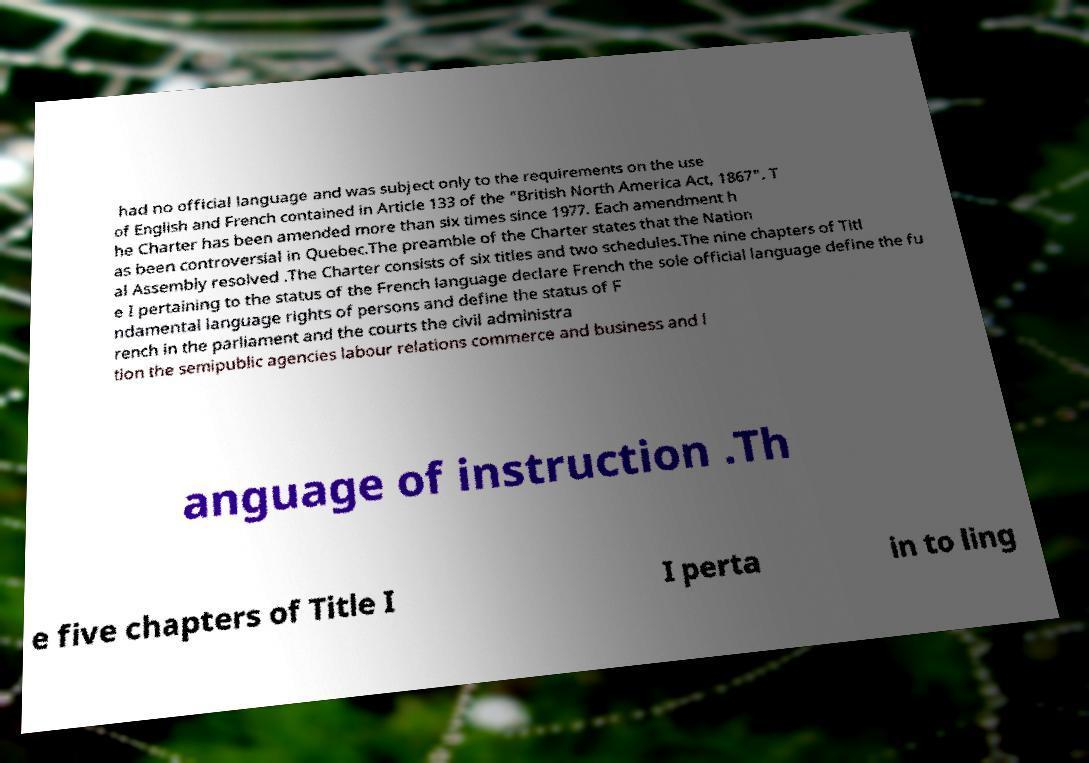Can you accurately transcribe the text from the provided image for me? had no official language and was subject only to the requirements on the use of English and French contained in Article 133 of the "British North America Act, 1867". T he Charter has been amended more than six times since 1977. Each amendment h as been controversial in Quebec.The preamble of the Charter states that the Nation al Assembly resolved .The Charter consists of six titles and two schedules.The nine chapters of Titl e I pertaining to the status of the French language declare French the sole official language define the fu ndamental language rights of persons and define the status of F rench in the parliament and the courts the civil administra tion the semipublic agencies labour relations commerce and business and l anguage of instruction .Th e five chapters of Title I I perta in to ling 